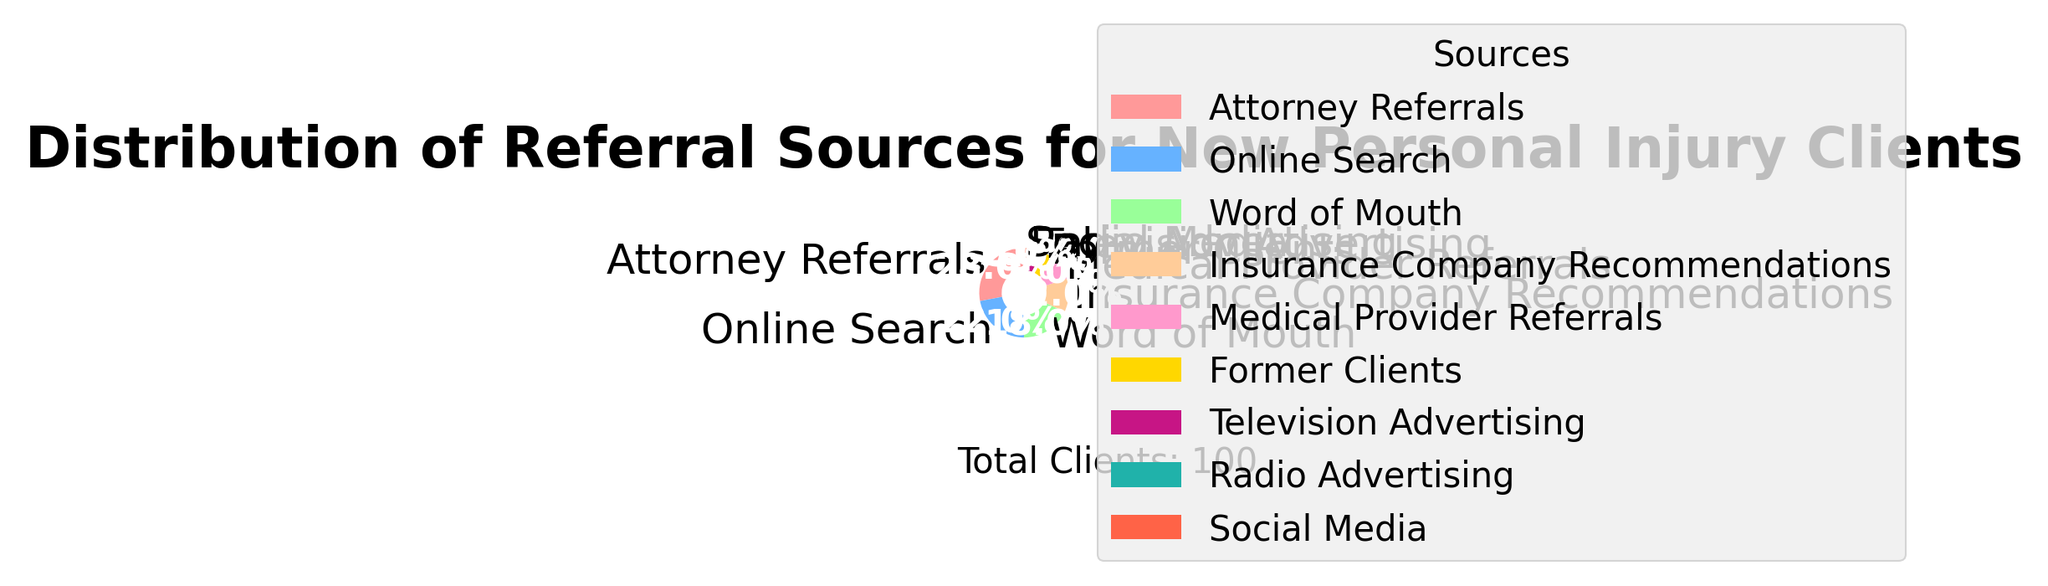Which referral source contributes the largest percentage of new personal injury clients? By looking at the pie chart, the segment with the largest size indicates the highest percentage. The "Attorney Referrals" segment is the largest.
Answer: Attorney Referrals What is the combined percentage of clients coming from "Word of Mouth" and "Former Clients"? Find the percentages for "Word of Mouth" (18%) and "Former Clients" (6%) and add them together: 18% + 6% = 24%.
Answer: 24% Are there more clients referred by "Online Search" or "Insurance Company Recommendations"? Compare the sizes of the segments for "Online Search" (22%) and "Insurance Company Recommendations" (12%). "Online Search" is larger.
Answer: Online Search What is the percentage difference between "Medical Provider Referrals" and "Television Advertising"? Subtract the percentage of "Television Advertising" (3%) from the percentage of "Medical Provider Referrals" (8%): 8% - 3% = 5%.
Answer: 5% Which referral source has the smallest share of new clients? The segment with the smallest size indicates the smallest share. The "Social Media" segment is the smallest with 1%.
Answer: Social Media What is the total percentage of clients referred by "Attorney Referrals", "Online Search", and "Word of Mouth" combined? Add the percentages for "Attorney Referrals" (28%), "Online Search" (22%), and "Word of Mouth" (18%): 28% + 22% + 18% = 68%.
Answer: 68% Is the percentage of clients from "Former Clients" greater than from "Radio Advertising"? Compare the percentages for "Former Clients" (6%) and "Radio Advertising" (2%). 6% is greater than 2%.
Answer: Yes How does the percentage of "Television Advertising" compare to "Radio Advertising"? Compare the percentages for "Television Advertising" (3%) and "Radio Advertising" (2%). 3% is larger than 2%.
Answer: Television Advertising is larger What is the percentage difference between the largest and the smallest referral sources? Subtract the percentage of the smallest source, "Social Media" (1%), from the largest source, "Attorney Referrals" (28%): 28% - 1% = 27%.
Answer: 27% How many sources have a percentage greater than 10%? Identify and count the sources with percentages greater than 10%: "Attorney Referrals" (28%), "Online Search" (22%), "Word of Mouth" (18%), "Insurance Company Recommendations" (12%). There are 4 such sources.
Answer: 4 